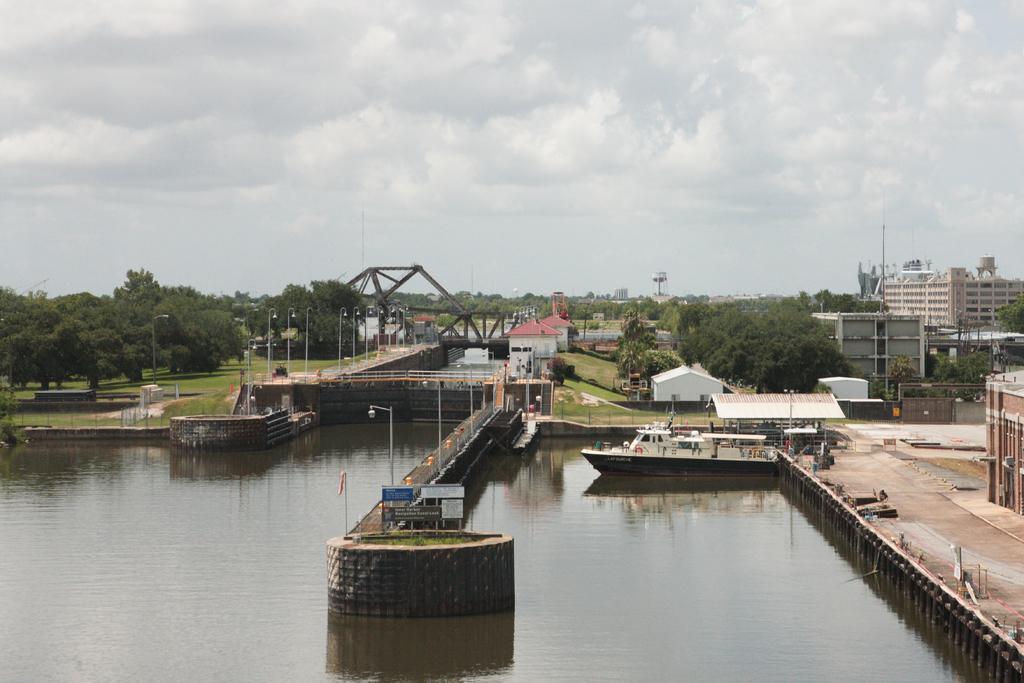In one or two sentences, can you explain what this image depicts? In the center of the image there is a wall in the water. On the wall, we can see the grass, sign boards and one flag. And we can see one bridge, one boat, gates, poles, fences and a few other objects. In the background, we can see the sky, clouds, one bridge, trees, grass, buildings, one shed and a few other objects. 